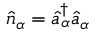Convert formula to latex. <formula><loc_0><loc_0><loc_500><loc_500>\hat { n } _ { \alpha } = \hat { a } _ { \alpha } ^ { \dagger } \hat { a } _ { \alpha }</formula> 